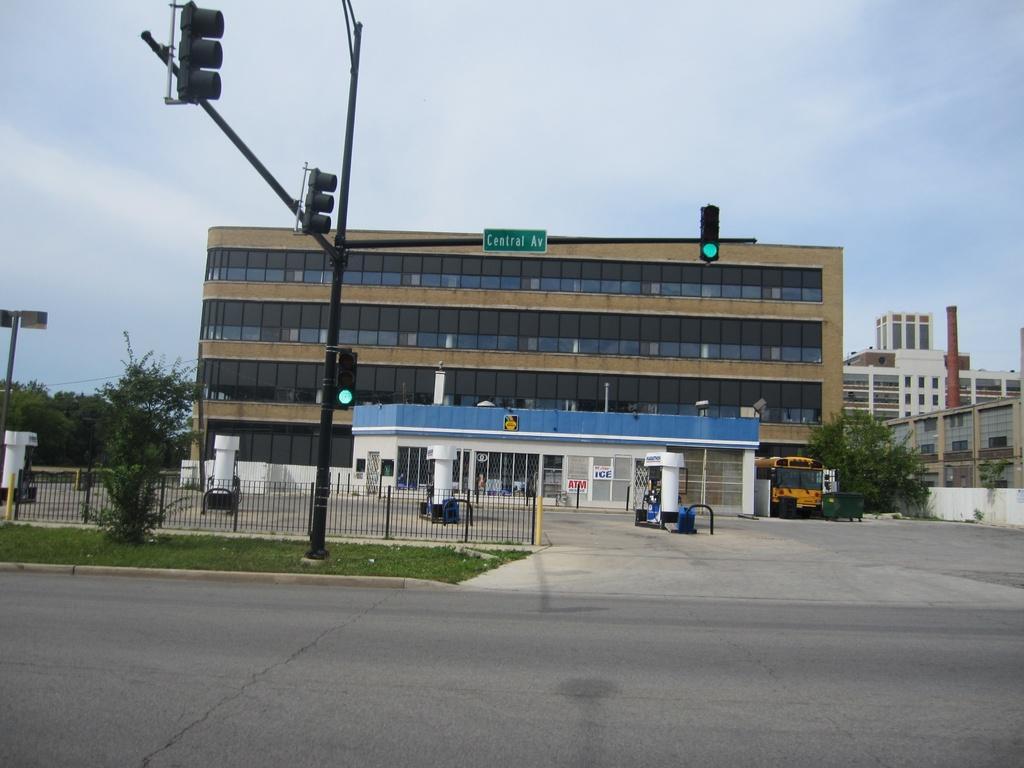Describe this image in one or two sentences. Here we can see buildings. There are trees, poles, traffic signals, boards, fence, grass and a vehicle. This is a road. In the background we can see sky. 